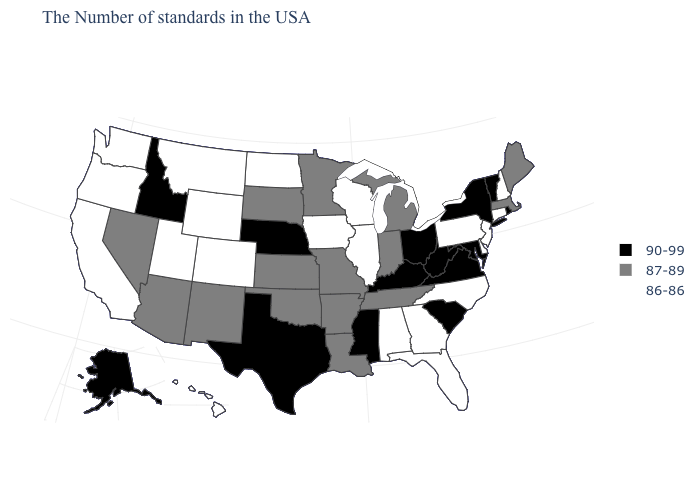Among the states that border Delaware , which have the lowest value?
Concise answer only. New Jersey, Pennsylvania. What is the value of New York?
Short answer required. 90-99. Among the states that border Tennessee , which have the lowest value?
Keep it brief. North Carolina, Georgia, Alabama. Among the states that border South Dakota , which have the highest value?
Short answer required. Nebraska. Among the states that border Minnesota , does South Dakota have the highest value?
Write a very short answer. Yes. What is the value of Oregon?
Quick response, please. 86-86. What is the lowest value in states that border New Jersey?
Write a very short answer. 86-86. Which states have the highest value in the USA?
Write a very short answer. Rhode Island, Vermont, New York, Maryland, Virginia, South Carolina, West Virginia, Ohio, Kentucky, Mississippi, Nebraska, Texas, Idaho, Alaska. Name the states that have a value in the range 90-99?
Be succinct. Rhode Island, Vermont, New York, Maryland, Virginia, South Carolina, West Virginia, Ohio, Kentucky, Mississippi, Nebraska, Texas, Idaho, Alaska. What is the value of Alabama?
Short answer required. 86-86. Among the states that border West Virginia , which have the lowest value?
Concise answer only. Pennsylvania. What is the value of Florida?
Concise answer only. 86-86. Does the first symbol in the legend represent the smallest category?
Keep it brief. No. Does North Dakota have the lowest value in the USA?
Answer briefly. Yes. 